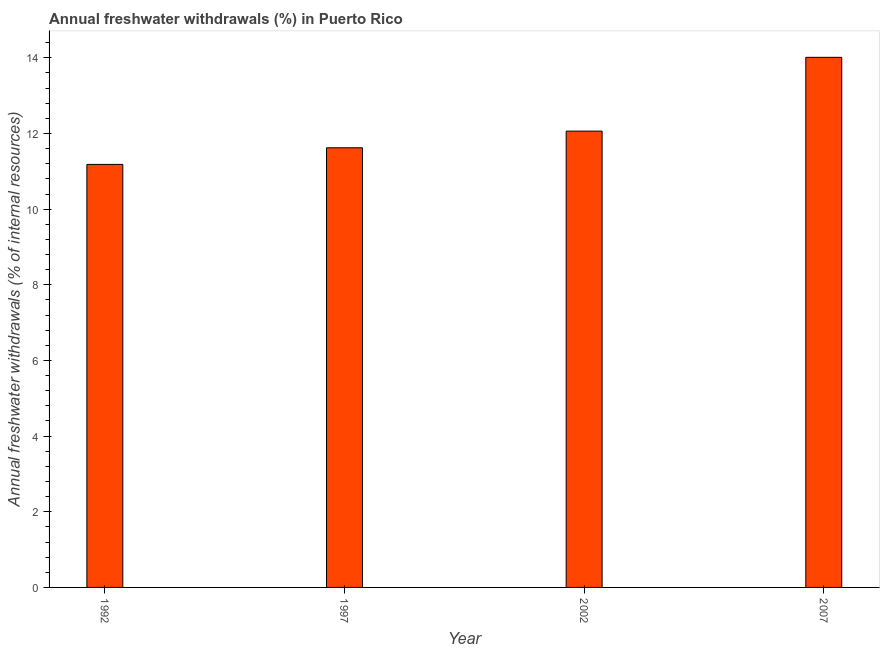Does the graph contain grids?
Provide a succinct answer. No. What is the title of the graph?
Offer a terse response. Annual freshwater withdrawals (%) in Puerto Rico. What is the label or title of the X-axis?
Keep it short and to the point. Year. What is the label or title of the Y-axis?
Your answer should be very brief. Annual freshwater withdrawals (% of internal resources). What is the annual freshwater withdrawals in 1997?
Your answer should be very brief. 11.62. Across all years, what is the maximum annual freshwater withdrawals?
Give a very brief answer. 14.01. Across all years, what is the minimum annual freshwater withdrawals?
Provide a succinct answer. 11.18. In which year was the annual freshwater withdrawals minimum?
Offer a terse response. 1992. What is the sum of the annual freshwater withdrawals?
Provide a succinct answer. 48.88. What is the difference between the annual freshwater withdrawals in 2002 and 2007?
Your response must be concise. -1.95. What is the average annual freshwater withdrawals per year?
Ensure brevity in your answer.  12.22. What is the median annual freshwater withdrawals?
Provide a short and direct response. 11.84. Is the difference between the annual freshwater withdrawals in 1992 and 2002 greater than the difference between any two years?
Ensure brevity in your answer.  No. What is the difference between the highest and the second highest annual freshwater withdrawals?
Make the answer very short. 1.95. Is the sum of the annual freshwater withdrawals in 1992 and 1997 greater than the maximum annual freshwater withdrawals across all years?
Offer a very short reply. Yes. What is the difference between the highest and the lowest annual freshwater withdrawals?
Keep it short and to the point. 2.83. How many bars are there?
Provide a short and direct response. 4. Are all the bars in the graph horizontal?
Provide a short and direct response. No. What is the difference between two consecutive major ticks on the Y-axis?
Ensure brevity in your answer.  2. What is the Annual freshwater withdrawals (% of internal resources) in 1992?
Give a very brief answer. 11.18. What is the Annual freshwater withdrawals (% of internal resources) in 1997?
Provide a short and direct response. 11.62. What is the Annual freshwater withdrawals (% of internal resources) in 2002?
Keep it short and to the point. 12.06. What is the Annual freshwater withdrawals (% of internal resources) in 2007?
Ensure brevity in your answer.  14.01. What is the difference between the Annual freshwater withdrawals (% of internal resources) in 1992 and 1997?
Offer a terse response. -0.44. What is the difference between the Annual freshwater withdrawals (% of internal resources) in 1992 and 2002?
Your response must be concise. -0.88. What is the difference between the Annual freshwater withdrawals (% of internal resources) in 1992 and 2007?
Give a very brief answer. -2.83. What is the difference between the Annual freshwater withdrawals (% of internal resources) in 1997 and 2002?
Your response must be concise. -0.44. What is the difference between the Annual freshwater withdrawals (% of internal resources) in 1997 and 2007?
Offer a very short reply. -2.39. What is the difference between the Annual freshwater withdrawals (% of internal resources) in 2002 and 2007?
Provide a succinct answer. -1.95. What is the ratio of the Annual freshwater withdrawals (% of internal resources) in 1992 to that in 2002?
Offer a very short reply. 0.93. What is the ratio of the Annual freshwater withdrawals (% of internal resources) in 1992 to that in 2007?
Your response must be concise. 0.8. What is the ratio of the Annual freshwater withdrawals (% of internal resources) in 1997 to that in 2002?
Give a very brief answer. 0.96. What is the ratio of the Annual freshwater withdrawals (% of internal resources) in 1997 to that in 2007?
Your answer should be very brief. 0.83. What is the ratio of the Annual freshwater withdrawals (% of internal resources) in 2002 to that in 2007?
Give a very brief answer. 0.86. 